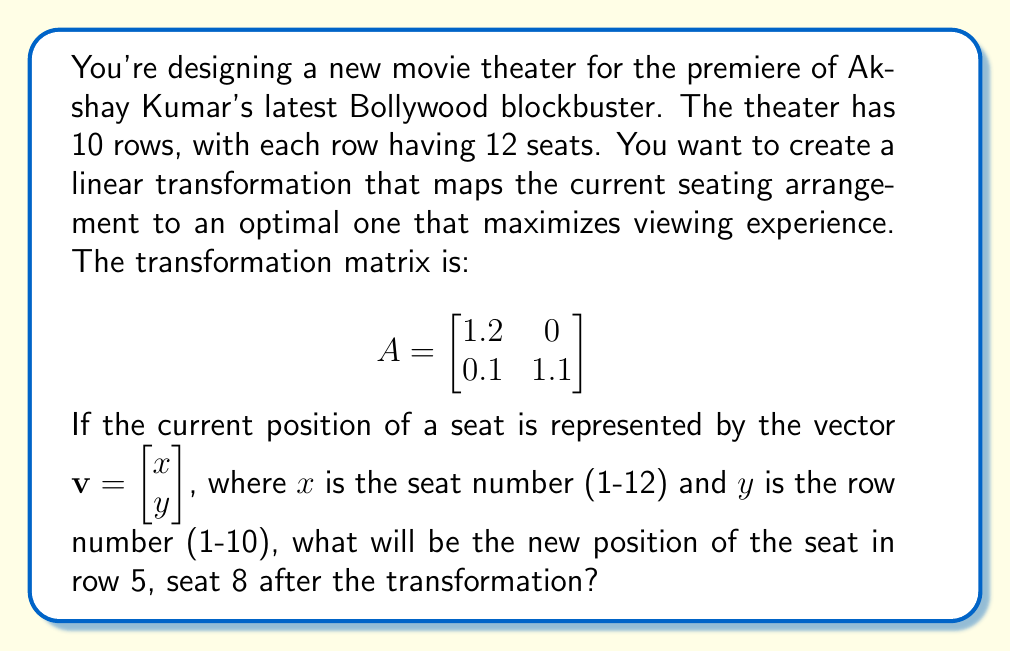Can you solve this math problem? Let's approach this step-by-step:

1) First, we need to represent the initial position of the seat as a vector. The seat is in row 5, seat 8, so:

   $\mathbf{v} = \begin{bmatrix} 8 \\ 5 \end{bmatrix}$

2) To find the new position, we need to apply the linear transformation represented by matrix $A$ to this vector. We do this by multiplying $A$ and $\mathbf{v}$:

   $A\mathbf{v} = \begin{bmatrix} 1.2 & 0 \\ 0.1 & 1.1 \end{bmatrix} \begin{bmatrix} 8 \\ 5 \end{bmatrix}$

3) Let's perform the matrix multiplication:

   $\begin{bmatrix} 1.2(8) + 0(5) \\ 0.1(8) + 1.1(5) \end{bmatrix}$

4) Simplifying:

   $\begin{bmatrix} 9.6 \\ 6.3 \end{bmatrix}$

5) Therefore, the new position of the seat will be at coordinates (9.6, 6.3) in the transformed seating arrangement.

This transformation has moved the seat slightly to the right (from 8 to 9.6) and back (from 5 to 6.3), potentially improving the viewing angle for this particular seat.
Answer: $(9.6, 6.3)$ 